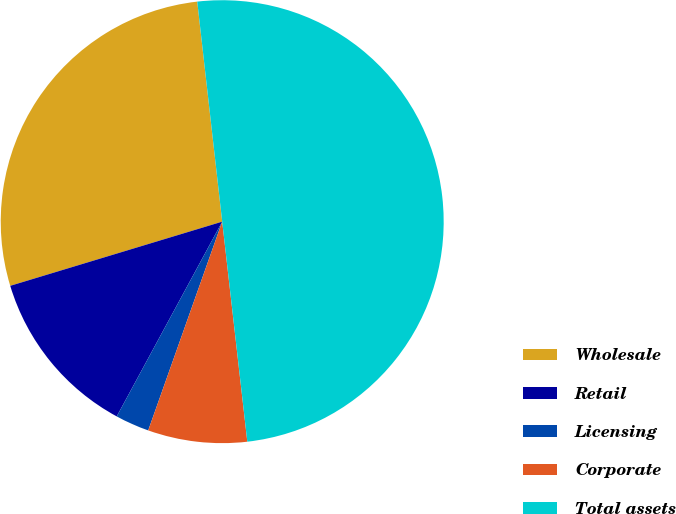Convert chart to OTSL. <chart><loc_0><loc_0><loc_500><loc_500><pie_chart><fcel>Wholesale<fcel>Retail<fcel>Licensing<fcel>Corporate<fcel>Total assets<nl><fcel>27.88%<fcel>12.42%<fcel>2.48%<fcel>7.23%<fcel>49.99%<nl></chart> 